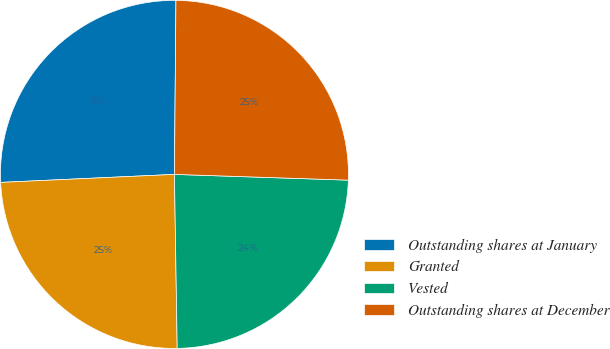<chart> <loc_0><loc_0><loc_500><loc_500><pie_chart><fcel>Outstanding shares at January<fcel>Granted<fcel>Vested<fcel>Outstanding shares at December<nl><fcel>25.87%<fcel>24.52%<fcel>24.22%<fcel>25.39%<nl></chart> 